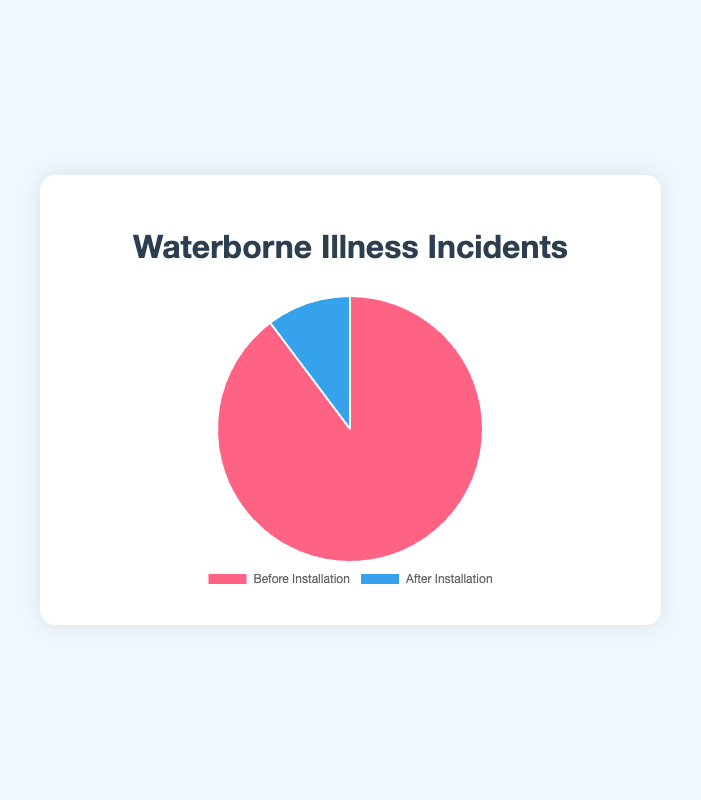What percentage of the incidents occurred before the installation? To find the percentage of incidents before the installation, divide the number of incidents before the installation (35) by the total number of incidents (35 + 4 = 39) and then multiply by 100. (35/39) * 100 = 89.74%
Answer: 89.74% What is the difference in the number of incidents before and after the installation? To determine the difference, subtract the number of incidents after the installation (4) from the number of incidents before the installation (35). 35 - 4 = 31
Answer: 31 How much did the incidents reduce in percentage terms after the installation? First, calculate the difference in incidents (35 - 4 = 31). Then divide this difference by the original number of incidents (35) and multiply by 100 to get the percentage reduction. (31/35) * 100 = 88.57%
Answer: 88.57% Which period had fewer incidents, before the installation or after the installation? By comparing the numbers, it's clear that there were fewer incidents after the installation (4) compared to before the installation (35).
Answer: After the installation What colors represent the periods before and after the installation in the chart? The chart uses colors to differentiate between the two periods. The period before installation is represented by red, and the period after installation is represented by blue.
Answer: Red and blue 